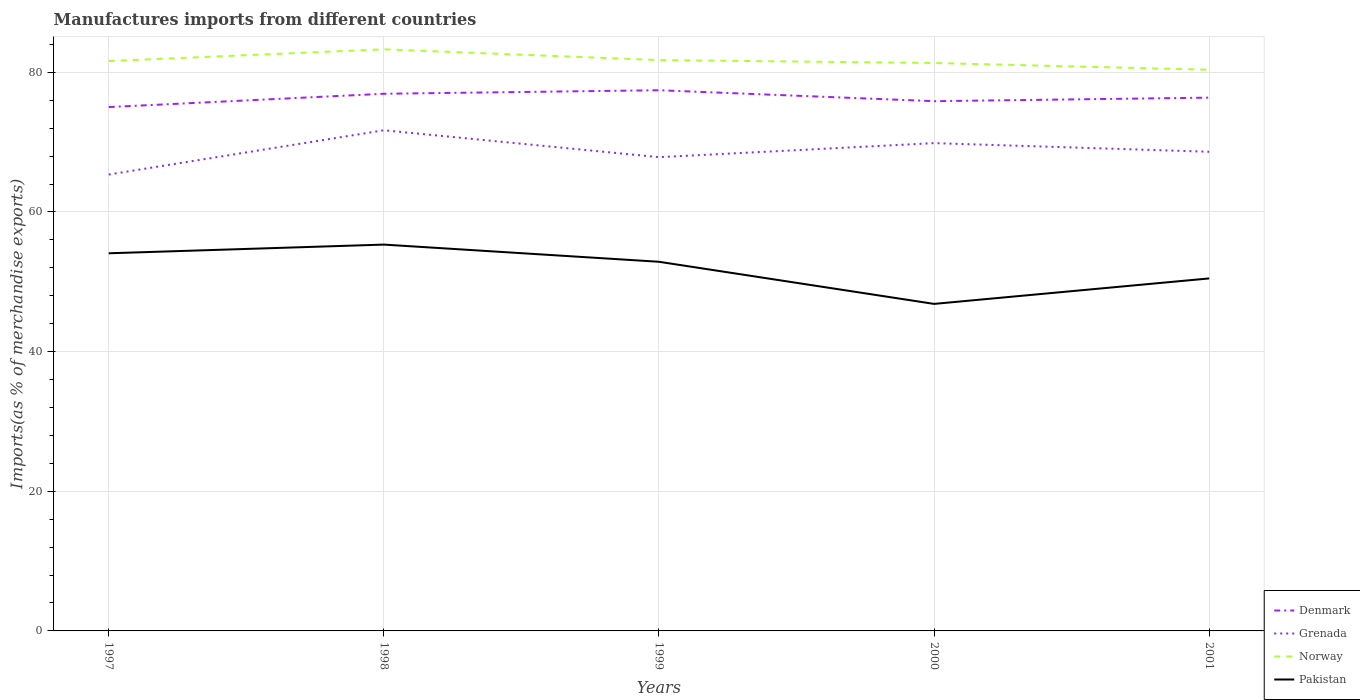Does the line corresponding to Grenada intersect with the line corresponding to Pakistan?
Provide a short and direct response. No. Across all years, what is the maximum percentage of imports to different countries in Pakistan?
Make the answer very short. 46.84. What is the total percentage of imports to different countries in Denmark in the graph?
Your response must be concise. 0.56. What is the difference between the highest and the second highest percentage of imports to different countries in Grenada?
Provide a succinct answer. 6.34. What is the difference between the highest and the lowest percentage of imports to different countries in Norway?
Give a very brief answer. 2. How many lines are there?
Your answer should be very brief. 4. How many years are there in the graph?
Your answer should be very brief. 5. What is the difference between two consecutive major ticks on the Y-axis?
Keep it short and to the point. 20. Are the values on the major ticks of Y-axis written in scientific E-notation?
Keep it short and to the point. No. Does the graph contain grids?
Your answer should be very brief. Yes. How are the legend labels stacked?
Your answer should be compact. Vertical. What is the title of the graph?
Your response must be concise. Manufactures imports from different countries. What is the label or title of the X-axis?
Offer a terse response. Years. What is the label or title of the Y-axis?
Make the answer very short. Imports(as % of merchandise exports). What is the Imports(as % of merchandise exports) in Denmark in 1997?
Your answer should be compact. 75.02. What is the Imports(as % of merchandise exports) in Grenada in 1997?
Your answer should be compact. 65.36. What is the Imports(as % of merchandise exports) of Norway in 1997?
Your answer should be very brief. 81.62. What is the Imports(as % of merchandise exports) of Pakistan in 1997?
Keep it short and to the point. 54.09. What is the Imports(as % of merchandise exports) in Denmark in 1998?
Provide a short and direct response. 76.93. What is the Imports(as % of merchandise exports) of Grenada in 1998?
Your answer should be compact. 71.7. What is the Imports(as % of merchandise exports) of Norway in 1998?
Give a very brief answer. 83.3. What is the Imports(as % of merchandise exports) in Pakistan in 1998?
Offer a terse response. 55.33. What is the Imports(as % of merchandise exports) in Denmark in 1999?
Your response must be concise. 77.44. What is the Imports(as % of merchandise exports) of Grenada in 1999?
Give a very brief answer. 67.85. What is the Imports(as % of merchandise exports) of Norway in 1999?
Give a very brief answer. 81.75. What is the Imports(as % of merchandise exports) in Pakistan in 1999?
Make the answer very short. 52.87. What is the Imports(as % of merchandise exports) in Denmark in 2000?
Your answer should be compact. 75.87. What is the Imports(as % of merchandise exports) of Grenada in 2000?
Give a very brief answer. 69.86. What is the Imports(as % of merchandise exports) in Norway in 2000?
Offer a terse response. 81.34. What is the Imports(as % of merchandise exports) of Pakistan in 2000?
Give a very brief answer. 46.84. What is the Imports(as % of merchandise exports) of Denmark in 2001?
Provide a short and direct response. 76.38. What is the Imports(as % of merchandise exports) in Grenada in 2001?
Ensure brevity in your answer.  68.62. What is the Imports(as % of merchandise exports) of Norway in 2001?
Offer a terse response. 80.37. What is the Imports(as % of merchandise exports) of Pakistan in 2001?
Make the answer very short. 50.48. Across all years, what is the maximum Imports(as % of merchandise exports) in Denmark?
Offer a very short reply. 77.44. Across all years, what is the maximum Imports(as % of merchandise exports) of Grenada?
Offer a very short reply. 71.7. Across all years, what is the maximum Imports(as % of merchandise exports) in Norway?
Your answer should be compact. 83.3. Across all years, what is the maximum Imports(as % of merchandise exports) in Pakistan?
Make the answer very short. 55.33. Across all years, what is the minimum Imports(as % of merchandise exports) of Denmark?
Your answer should be compact. 75.02. Across all years, what is the minimum Imports(as % of merchandise exports) of Grenada?
Provide a short and direct response. 65.36. Across all years, what is the minimum Imports(as % of merchandise exports) of Norway?
Provide a short and direct response. 80.37. Across all years, what is the minimum Imports(as % of merchandise exports) in Pakistan?
Offer a very short reply. 46.84. What is the total Imports(as % of merchandise exports) in Denmark in the graph?
Offer a very short reply. 381.63. What is the total Imports(as % of merchandise exports) of Grenada in the graph?
Provide a short and direct response. 343.4. What is the total Imports(as % of merchandise exports) in Norway in the graph?
Give a very brief answer. 408.38. What is the total Imports(as % of merchandise exports) of Pakistan in the graph?
Provide a short and direct response. 259.61. What is the difference between the Imports(as % of merchandise exports) in Denmark in 1997 and that in 1998?
Your answer should be very brief. -1.91. What is the difference between the Imports(as % of merchandise exports) of Grenada in 1997 and that in 1998?
Provide a succinct answer. -6.34. What is the difference between the Imports(as % of merchandise exports) in Norway in 1997 and that in 1998?
Offer a very short reply. -1.68. What is the difference between the Imports(as % of merchandise exports) of Pakistan in 1997 and that in 1998?
Provide a succinct answer. -1.24. What is the difference between the Imports(as % of merchandise exports) of Denmark in 1997 and that in 1999?
Give a very brief answer. -2.41. What is the difference between the Imports(as % of merchandise exports) of Grenada in 1997 and that in 1999?
Provide a succinct answer. -2.49. What is the difference between the Imports(as % of merchandise exports) in Norway in 1997 and that in 1999?
Make the answer very short. -0.14. What is the difference between the Imports(as % of merchandise exports) in Pakistan in 1997 and that in 1999?
Provide a succinct answer. 1.22. What is the difference between the Imports(as % of merchandise exports) in Denmark in 1997 and that in 2000?
Your answer should be very brief. -0.84. What is the difference between the Imports(as % of merchandise exports) in Grenada in 1997 and that in 2000?
Your response must be concise. -4.5. What is the difference between the Imports(as % of merchandise exports) in Norway in 1997 and that in 2000?
Ensure brevity in your answer.  0.28. What is the difference between the Imports(as % of merchandise exports) in Pakistan in 1997 and that in 2000?
Make the answer very short. 7.25. What is the difference between the Imports(as % of merchandise exports) in Denmark in 1997 and that in 2001?
Provide a succinct answer. -1.35. What is the difference between the Imports(as % of merchandise exports) in Grenada in 1997 and that in 2001?
Your answer should be very brief. -3.26. What is the difference between the Imports(as % of merchandise exports) of Norway in 1997 and that in 2001?
Give a very brief answer. 1.25. What is the difference between the Imports(as % of merchandise exports) in Pakistan in 1997 and that in 2001?
Your answer should be compact. 3.6. What is the difference between the Imports(as % of merchandise exports) of Denmark in 1998 and that in 1999?
Make the answer very short. -0.51. What is the difference between the Imports(as % of merchandise exports) of Grenada in 1998 and that in 1999?
Ensure brevity in your answer.  3.85. What is the difference between the Imports(as % of merchandise exports) of Norway in 1998 and that in 1999?
Ensure brevity in your answer.  1.54. What is the difference between the Imports(as % of merchandise exports) of Pakistan in 1998 and that in 1999?
Keep it short and to the point. 2.46. What is the difference between the Imports(as % of merchandise exports) of Denmark in 1998 and that in 2000?
Offer a very short reply. 1.06. What is the difference between the Imports(as % of merchandise exports) of Grenada in 1998 and that in 2000?
Offer a very short reply. 1.84. What is the difference between the Imports(as % of merchandise exports) of Norway in 1998 and that in 2000?
Keep it short and to the point. 1.96. What is the difference between the Imports(as % of merchandise exports) of Pakistan in 1998 and that in 2000?
Make the answer very short. 8.49. What is the difference between the Imports(as % of merchandise exports) of Denmark in 1998 and that in 2001?
Provide a succinct answer. 0.56. What is the difference between the Imports(as % of merchandise exports) of Grenada in 1998 and that in 2001?
Ensure brevity in your answer.  3.08. What is the difference between the Imports(as % of merchandise exports) of Norway in 1998 and that in 2001?
Provide a succinct answer. 2.93. What is the difference between the Imports(as % of merchandise exports) in Pakistan in 1998 and that in 2001?
Provide a short and direct response. 4.85. What is the difference between the Imports(as % of merchandise exports) in Denmark in 1999 and that in 2000?
Keep it short and to the point. 1.57. What is the difference between the Imports(as % of merchandise exports) of Grenada in 1999 and that in 2000?
Your answer should be compact. -2.01. What is the difference between the Imports(as % of merchandise exports) in Norway in 1999 and that in 2000?
Keep it short and to the point. 0.41. What is the difference between the Imports(as % of merchandise exports) of Pakistan in 1999 and that in 2000?
Your answer should be compact. 6.03. What is the difference between the Imports(as % of merchandise exports) in Denmark in 1999 and that in 2001?
Offer a very short reply. 1.06. What is the difference between the Imports(as % of merchandise exports) of Grenada in 1999 and that in 2001?
Provide a short and direct response. -0.78. What is the difference between the Imports(as % of merchandise exports) in Norway in 1999 and that in 2001?
Your answer should be compact. 1.39. What is the difference between the Imports(as % of merchandise exports) in Pakistan in 1999 and that in 2001?
Make the answer very short. 2.38. What is the difference between the Imports(as % of merchandise exports) of Denmark in 2000 and that in 2001?
Your response must be concise. -0.51. What is the difference between the Imports(as % of merchandise exports) in Grenada in 2000 and that in 2001?
Your answer should be compact. 1.24. What is the difference between the Imports(as % of merchandise exports) of Norway in 2000 and that in 2001?
Offer a very short reply. 0.97. What is the difference between the Imports(as % of merchandise exports) in Pakistan in 2000 and that in 2001?
Your answer should be compact. -3.65. What is the difference between the Imports(as % of merchandise exports) of Denmark in 1997 and the Imports(as % of merchandise exports) of Grenada in 1998?
Give a very brief answer. 3.32. What is the difference between the Imports(as % of merchandise exports) in Denmark in 1997 and the Imports(as % of merchandise exports) in Norway in 1998?
Your response must be concise. -8.27. What is the difference between the Imports(as % of merchandise exports) in Denmark in 1997 and the Imports(as % of merchandise exports) in Pakistan in 1998?
Your answer should be very brief. 19.69. What is the difference between the Imports(as % of merchandise exports) in Grenada in 1997 and the Imports(as % of merchandise exports) in Norway in 1998?
Offer a very short reply. -17.94. What is the difference between the Imports(as % of merchandise exports) of Grenada in 1997 and the Imports(as % of merchandise exports) of Pakistan in 1998?
Give a very brief answer. 10.03. What is the difference between the Imports(as % of merchandise exports) of Norway in 1997 and the Imports(as % of merchandise exports) of Pakistan in 1998?
Your response must be concise. 26.29. What is the difference between the Imports(as % of merchandise exports) in Denmark in 1997 and the Imports(as % of merchandise exports) in Grenada in 1999?
Give a very brief answer. 7.17. What is the difference between the Imports(as % of merchandise exports) of Denmark in 1997 and the Imports(as % of merchandise exports) of Norway in 1999?
Keep it short and to the point. -6.73. What is the difference between the Imports(as % of merchandise exports) of Denmark in 1997 and the Imports(as % of merchandise exports) of Pakistan in 1999?
Keep it short and to the point. 22.16. What is the difference between the Imports(as % of merchandise exports) in Grenada in 1997 and the Imports(as % of merchandise exports) in Norway in 1999?
Your response must be concise. -16.39. What is the difference between the Imports(as % of merchandise exports) of Grenada in 1997 and the Imports(as % of merchandise exports) of Pakistan in 1999?
Provide a short and direct response. 12.49. What is the difference between the Imports(as % of merchandise exports) in Norway in 1997 and the Imports(as % of merchandise exports) in Pakistan in 1999?
Offer a terse response. 28.75. What is the difference between the Imports(as % of merchandise exports) in Denmark in 1997 and the Imports(as % of merchandise exports) in Grenada in 2000?
Make the answer very short. 5.16. What is the difference between the Imports(as % of merchandise exports) in Denmark in 1997 and the Imports(as % of merchandise exports) in Norway in 2000?
Ensure brevity in your answer.  -6.32. What is the difference between the Imports(as % of merchandise exports) in Denmark in 1997 and the Imports(as % of merchandise exports) in Pakistan in 2000?
Give a very brief answer. 28.19. What is the difference between the Imports(as % of merchandise exports) in Grenada in 1997 and the Imports(as % of merchandise exports) in Norway in 2000?
Make the answer very short. -15.98. What is the difference between the Imports(as % of merchandise exports) in Grenada in 1997 and the Imports(as % of merchandise exports) in Pakistan in 2000?
Your answer should be very brief. 18.53. What is the difference between the Imports(as % of merchandise exports) in Norway in 1997 and the Imports(as % of merchandise exports) in Pakistan in 2000?
Give a very brief answer. 34.78. What is the difference between the Imports(as % of merchandise exports) of Denmark in 1997 and the Imports(as % of merchandise exports) of Grenada in 2001?
Give a very brief answer. 6.4. What is the difference between the Imports(as % of merchandise exports) of Denmark in 1997 and the Imports(as % of merchandise exports) of Norway in 2001?
Your response must be concise. -5.34. What is the difference between the Imports(as % of merchandise exports) in Denmark in 1997 and the Imports(as % of merchandise exports) in Pakistan in 2001?
Ensure brevity in your answer.  24.54. What is the difference between the Imports(as % of merchandise exports) of Grenada in 1997 and the Imports(as % of merchandise exports) of Norway in 2001?
Your answer should be very brief. -15. What is the difference between the Imports(as % of merchandise exports) in Grenada in 1997 and the Imports(as % of merchandise exports) in Pakistan in 2001?
Your response must be concise. 14.88. What is the difference between the Imports(as % of merchandise exports) in Norway in 1997 and the Imports(as % of merchandise exports) in Pakistan in 2001?
Your answer should be compact. 31.13. What is the difference between the Imports(as % of merchandise exports) of Denmark in 1998 and the Imports(as % of merchandise exports) of Grenada in 1999?
Your answer should be very brief. 9.08. What is the difference between the Imports(as % of merchandise exports) of Denmark in 1998 and the Imports(as % of merchandise exports) of Norway in 1999?
Keep it short and to the point. -4.82. What is the difference between the Imports(as % of merchandise exports) of Denmark in 1998 and the Imports(as % of merchandise exports) of Pakistan in 1999?
Provide a short and direct response. 24.06. What is the difference between the Imports(as % of merchandise exports) of Grenada in 1998 and the Imports(as % of merchandise exports) of Norway in 1999?
Offer a terse response. -10.05. What is the difference between the Imports(as % of merchandise exports) of Grenada in 1998 and the Imports(as % of merchandise exports) of Pakistan in 1999?
Your answer should be compact. 18.83. What is the difference between the Imports(as % of merchandise exports) in Norway in 1998 and the Imports(as % of merchandise exports) in Pakistan in 1999?
Make the answer very short. 30.43. What is the difference between the Imports(as % of merchandise exports) of Denmark in 1998 and the Imports(as % of merchandise exports) of Grenada in 2000?
Offer a terse response. 7.07. What is the difference between the Imports(as % of merchandise exports) in Denmark in 1998 and the Imports(as % of merchandise exports) in Norway in 2000?
Give a very brief answer. -4.41. What is the difference between the Imports(as % of merchandise exports) in Denmark in 1998 and the Imports(as % of merchandise exports) in Pakistan in 2000?
Make the answer very short. 30.09. What is the difference between the Imports(as % of merchandise exports) in Grenada in 1998 and the Imports(as % of merchandise exports) in Norway in 2000?
Your answer should be compact. -9.64. What is the difference between the Imports(as % of merchandise exports) of Grenada in 1998 and the Imports(as % of merchandise exports) of Pakistan in 2000?
Your answer should be very brief. 24.87. What is the difference between the Imports(as % of merchandise exports) in Norway in 1998 and the Imports(as % of merchandise exports) in Pakistan in 2000?
Provide a succinct answer. 36.46. What is the difference between the Imports(as % of merchandise exports) in Denmark in 1998 and the Imports(as % of merchandise exports) in Grenada in 2001?
Give a very brief answer. 8.31. What is the difference between the Imports(as % of merchandise exports) in Denmark in 1998 and the Imports(as % of merchandise exports) in Norway in 2001?
Provide a succinct answer. -3.44. What is the difference between the Imports(as % of merchandise exports) in Denmark in 1998 and the Imports(as % of merchandise exports) in Pakistan in 2001?
Your response must be concise. 26.45. What is the difference between the Imports(as % of merchandise exports) in Grenada in 1998 and the Imports(as % of merchandise exports) in Norway in 2001?
Your response must be concise. -8.66. What is the difference between the Imports(as % of merchandise exports) in Grenada in 1998 and the Imports(as % of merchandise exports) in Pakistan in 2001?
Give a very brief answer. 21.22. What is the difference between the Imports(as % of merchandise exports) of Norway in 1998 and the Imports(as % of merchandise exports) of Pakistan in 2001?
Your answer should be compact. 32.81. What is the difference between the Imports(as % of merchandise exports) in Denmark in 1999 and the Imports(as % of merchandise exports) in Grenada in 2000?
Provide a short and direct response. 7.57. What is the difference between the Imports(as % of merchandise exports) in Denmark in 1999 and the Imports(as % of merchandise exports) in Norway in 2000?
Offer a terse response. -3.9. What is the difference between the Imports(as % of merchandise exports) of Denmark in 1999 and the Imports(as % of merchandise exports) of Pakistan in 2000?
Offer a terse response. 30.6. What is the difference between the Imports(as % of merchandise exports) of Grenada in 1999 and the Imports(as % of merchandise exports) of Norway in 2000?
Your response must be concise. -13.49. What is the difference between the Imports(as % of merchandise exports) in Grenada in 1999 and the Imports(as % of merchandise exports) in Pakistan in 2000?
Keep it short and to the point. 21.01. What is the difference between the Imports(as % of merchandise exports) of Norway in 1999 and the Imports(as % of merchandise exports) of Pakistan in 2000?
Your response must be concise. 34.92. What is the difference between the Imports(as % of merchandise exports) in Denmark in 1999 and the Imports(as % of merchandise exports) in Grenada in 2001?
Your answer should be compact. 8.81. What is the difference between the Imports(as % of merchandise exports) in Denmark in 1999 and the Imports(as % of merchandise exports) in Norway in 2001?
Keep it short and to the point. -2.93. What is the difference between the Imports(as % of merchandise exports) in Denmark in 1999 and the Imports(as % of merchandise exports) in Pakistan in 2001?
Make the answer very short. 26.95. What is the difference between the Imports(as % of merchandise exports) in Grenada in 1999 and the Imports(as % of merchandise exports) in Norway in 2001?
Your response must be concise. -12.52. What is the difference between the Imports(as % of merchandise exports) in Grenada in 1999 and the Imports(as % of merchandise exports) in Pakistan in 2001?
Your response must be concise. 17.36. What is the difference between the Imports(as % of merchandise exports) of Norway in 1999 and the Imports(as % of merchandise exports) of Pakistan in 2001?
Keep it short and to the point. 31.27. What is the difference between the Imports(as % of merchandise exports) in Denmark in 2000 and the Imports(as % of merchandise exports) in Grenada in 2001?
Offer a terse response. 7.24. What is the difference between the Imports(as % of merchandise exports) in Denmark in 2000 and the Imports(as % of merchandise exports) in Norway in 2001?
Keep it short and to the point. -4.5. What is the difference between the Imports(as % of merchandise exports) in Denmark in 2000 and the Imports(as % of merchandise exports) in Pakistan in 2001?
Offer a very short reply. 25.38. What is the difference between the Imports(as % of merchandise exports) in Grenada in 2000 and the Imports(as % of merchandise exports) in Norway in 2001?
Offer a very short reply. -10.51. What is the difference between the Imports(as % of merchandise exports) of Grenada in 2000 and the Imports(as % of merchandise exports) of Pakistan in 2001?
Make the answer very short. 19.38. What is the difference between the Imports(as % of merchandise exports) of Norway in 2000 and the Imports(as % of merchandise exports) of Pakistan in 2001?
Provide a short and direct response. 30.86. What is the average Imports(as % of merchandise exports) of Denmark per year?
Make the answer very short. 76.33. What is the average Imports(as % of merchandise exports) in Grenada per year?
Ensure brevity in your answer.  68.68. What is the average Imports(as % of merchandise exports) in Norway per year?
Your response must be concise. 81.68. What is the average Imports(as % of merchandise exports) in Pakistan per year?
Give a very brief answer. 51.92. In the year 1997, what is the difference between the Imports(as % of merchandise exports) in Denmark and Imports(as % of merchandise exports) in Grenada?
Your answer should be compact. 9.66. In the year 1997, what is the difference between the Imports(as % of merchandise exports) in Denmark and Imports(as % of merchandise exports) in Norway?
Provide a succinct answer. -6.59. In the year 1997, what is the difference between the Imports(as % of merchandise exports) in Denmark and Imports(as % of merchandise exports) in Pakistan?
Your response must be concise. 20.94. In the year 1997, what is the difference between the Imports(as % of merchandise exports) of Grenada and Imports(as % of merchandise exports) of Norway?
Keep it short and to the point. -16.25. In the year 1997, what is the difference between the Imports(as % of merchandise exports) of Grenada and Imports(as % of merchandise exports) of Pakistan?
Give a very brief answer. 11.28. In the year 1997, what is the difference between the Imports(as % of merchandise exports) of Norway and Imports(as % of merchandise exports) of Pakistan?
Offer a terse response. 27.53. In the year 1998, what is the difference between the Imports(as % of merchandise exports) of Denmark and Imports(as % of merchandise exports) of Grenada?
Make the answer very short. 5.23. In the year 1998, what is the difference between the Imports(as % of merchandise exports) of Denmark and Imports(as % of merchandise exports) of Norway?
Keep it short and to the point. -6.37. In the year 1998, what is the difference between the Imports(as % of merchandise exports) in Denmark and Imports(as % of merchandise exports) in Pakistan?
Offer a terse response. 21.6. In the year 1998, what is the difference between the Imports(as % of merchandise exports) in Grenada and Imports(as % of merchandise exports) in Norway?
Your answer should be compact. -11.6. In the year 1998, what is the difference between the Imports(as % of merchandise exports) in Grenada and Imports(as % of merchandise exports) in Pakistan?
Offer a terse response. 16.37. In the year 1998, what is the difference between the Imports(as % of merchandise exports) in Norway and Imports(as % of merchandise exports) in Pakistan?
Your answer should be very brief. 27.97. In the year 1999, what is the difference between the Imports(as % of merchandise exports) in Denmark and Imports(as % of merchandise exports) in Grenada?
Your response must be concise. 9.59. In the year 1999, what is the difference between the Imports(as % of merchandise exports) of Denmark and Imports(as % of merchandise exports) of Norway?
Give a very brief answer. -4.32. In the year 1999, what is the difference between the Imports(as % of merchandise exports) of Denmark and Imports(as % of merchandise exports) of Pakistan?
Make the answer very short. 24.57. In the year 1999, what is the difference between the Imports(as % of merchandise exports) in Grenada and Imports(as % of merchandise exports) in Norway?
Give a very brief answer. -13.91. In the year 1999, what is the difference between the Imports(as % of merchandise exports) in Grenada and Imports(as % of merchandise exports) in Pakistan?
Ensure brevity in your answer.  14.98. In the year 1999, what is the difference between the Imports(as % of merchandise exports) of Norway and Imports(as % of merchandise exports) of Pakistan?
Offer a very short reply. 28.89. In the year 2000, what is the difference between the Imports(as % of merchandise exports) of Denmark and Imports(as % of merchandise exports) of Grenada?
Your response must be concise. 6.01. In the year 2000, what is the difference between the Imports(as % of merchandise exports) in Denmark and Imports(as % of merchandise exports) in Norway?
Offer a terse response. -5.47. In the year 2000, what is the difference between the Imports(as % of merchandise exports) of Denmark and Imports(as % of merchandise exports) of Pakistan?
Make the answer very short. 29.03. In the year 2000, what is the difference between the Imports(as % of merchandise exports) of Grenada and Imports(as % of merchandise exports) of Norway?
Provide a succinct answer. -11.48. In the year 2000, what is the difference between the Imports(as % of merchandise exports) of Grenada and Imports(as % of merchandise exports) of Pakistan?
Your answer should be compact. 23.03. In the year 2000, what is the difference between the Imports(as % of merchandise exports) of Norway and Imports(as % of merchandise exports) of Pakistan?
Give a very brief answer. 34.5. In the year 2001, what is the difference between the Imports(as % of merchandise exports) in Denmark and Imports(as % of merchandise exports) in Grenada?
Give a very brief answer. 7.75. In the year 2001, what is the difference between the Imports(as % of merchandise exports) in Denmark and Imports(as % of merchandise exports) in Norway?
Give a very brief answer. -3.99. In the year 2001, what is the difference between the Imports(as % of merchandise exports) of Denmark and Imports(as % of merchandise exports) of Pakistan?
Make the answer very short. 25.89. In the year 2001, what is the difference between the Imports(as % of merchandise exports) in Grenada and Imports(as % of merchandise exports) in Norway?
Your answer should be compact. -11.74. In the year 2001, what is the difference between the Imports(as % of merchandise exports) in Grenada and Imports(as % of merchandise exports) in Pakistan?
Give a very brief answer. 18.14. In the year 2001, what is the difference between the Imports(as % of merchandise exports) of Norway and Imports(as % of merchandise exports) of Pakistan?
Offer a terse response. 29.88. What is the ratio of the Imports(as % of merchandise exports) of Denmark in 1997 to that in 1998?
Make the answer very short. 0.98. What is the ratio of the Imports(as % of merchandise exports) in Grenada in 1997 to that in 1998?
Provide a short and direct response. 0.91. What is the ratio of the Imports(as % of merchandise exports) in Norway in 1997 to that in 1998?
Keep it short and to the point. 0.98. What is the ratio of the Imports(as % of merchandise exports) in Pakistan in 1997 to that in 1998?
Make the answer very short. 0.98. What is the ratio of the Imports(as % of merchandise exports) in Denmark in 1997 to that in 1999?
Provide a succinct answer. 0.97. What is the ratio of the Imports(as % of merchandise exports) of Grenada in 1997 to that in 1999?
Provide a succinct answer. 0.96. What is the ratio of the Imports(as % of merchandise exports) of Pakistan in 1997 to that in 1999?
Provide a short and direct response. 1.02. What is the ratio of the Imports(as % of merchandise exports) in Denmark in 1997 to that in 2000?
Make the answer very short. 0.99. What is the ratio of the Imports(as % of merchandise exports) of Grenada in 1997 to that in 2000?
Keep it short and to the point. 0.94. What is the ratio of the Imports(as % of merchandise exports) of Norway in 1997 to that in 2000?
Your answer should be very brief. 1. What is the ratio of the Imports(as % of merchandise exports) in Pakistan in 1997 to that in 2000?
Provide a short and direct response. 1.15. What is the ratio of the Imports(as % of merchandise exports) of Denmark in 1997 to that in 2001?
Your answer should be very brief. 0.98. What is the ratio of the Imports(as % of merchandise exports) of Grenada in 1997 to that in 2001?
Offer a very short reply. 0.95. What is the ratio of the Imports(as % of merchandise exports) of Norway in 1997 to that in 2001?
Offer a very short reply. 1.02. What is the ratio of the Imports(as % of merchandise exports) of Pakistan in 1997 to that in 2001?
Give a very brief answer. 1.07. What is the ratio of the Imports(as % of merchandise exports) in Grenada in 1998 to that in 1999?
Make the answer very short. 1.06. What is the ratio of the Imports(as % of merchandise exports) of Norway in 1998 to that in 1999?
Your response must be concise. 1.02. What is the ratio of the Imports(as % of merchandise exports) of Pakistan in 1998 to that in 1999?
Give a very brief answer. 1.05. What is the ratio of the Imports(as % of merchandise exports) in Denmark in 1998 to that in 2000?
Your answer should be very brief. 1.01. What is the ratio of the Imports(as % of merchandise exports) of Grenada in 1998 to that in 2000?
Keep it short and to the point. 1.03. What is the ratio of the Imports(as % of merchandise exports) in Norway in 1998 to that in 2000?
Keep it short and to the point. 1.02. What is the ratio of the Imports(as % of merchandise exports) in Pakistan in 1998 to that in 2000?
Offer a terse response. 1.18. What is the ratio of the Imports(as % of merchandise exports) of Denmark in 1998 to that in 2001?
Make the answer very short. 1.01. What is the ratio of the Imports(as % of merchandise exports) of Grenada in 1998 to that in 2001?
Offer a terse response. 1.04. What is the ratio of the Imports(as % of merchandise exports) of Norway in 1998 to that in 2001?
Provide a succinct answer. 1.04. What is the ratio of the Imports(as % of merchandise exports) of Pakistan in 1998 to that in 2001?
Give a very brief answer. 1.1. What is the ratio of the Imports(as % of merchandise exports) of Denmark in 1999 to that in 2000?
Your response must be concise. 1.02. What is the ratio of the Imports(as % of merchandise exports) of Grenada in 1999 to that in 2000?
Offer a very short reply. 0.97. What is the ratio of the Imports(as % of merchandise exports) in Norway in 1999 to that in 2000?
Offer a very short reply. 1.01. What is the ratio of the Imports(as % of merchandise exports) of Pakistan in 1999 to that in 2000?
Offer a very short reply. 1.13. What is the ratio of the Imports(as % of merchandise exports) in Denmark in 1999 to that in 2001?
Keep it short and to the point. 1.01. What is the ratio of the Imports(as % of merchandise exports) of Grenada in 1999 to that in 2001?
Provide a succinct answer. 0.99. What is the ratio of the Imports(as % of merchandise exports) in Norway in 1999 to that in 2001?
Provide a short and direct response. 1.02. What is the ratio of the Imports(as % of merchandise exports) of Pakistan in 1999 to that in 2001?
Your response must be concise. 1.05. What is the ratio of the Imports(as % of merchandise exports) of Grenada in 2000 to that in 2001?
Offer a very short reply. 1.02. What is the ratio of the Imports(as % of merchandise exports) of Norway in 2000 to that in 2001?
Your answer should be compact. 1.01. What is the ratio of the Imports(as % of merchandise exports) in Pakistan in 2000 to that in 2001?
Offer a very short reply. 0.93. What is the difference between the highest and the second highest Imports(as % of merchandise exports) in Denmark?
Ensure brevity in your answer.  0.51. What is the difference between the highest and the second highest Imports(as % of merchandise exports) in Grenada?
Keep it short and to the point. 1.84. What is the difference between the highest and the second highest Imports(as % of merchandise exports) in Norway?
Your answer should be very brief. 1.54. What is the difference between the highest and the second highest Imports(as % of merchandise exports) of Pakistan?
Provide a succinct answer. 1.24. What is the difference between the highest and the lowest Imports(as % of merchandise exports) in Denmark?
Your response must be concise. 2.41. What is the difference between the highest and the lowest Imports(as % of merchandise exports) in Grenada?
Keep it short and to the point. 6.34. What is the difference between the highest and the lowest Imports(as % of merchandise exports) of Norway?
Give a very brief answer. 2.93. What is the difference between the highest and the lowest Imports(as % of merchandise exports) of Pakistan?
Your answer should be very brief. 8.49. 